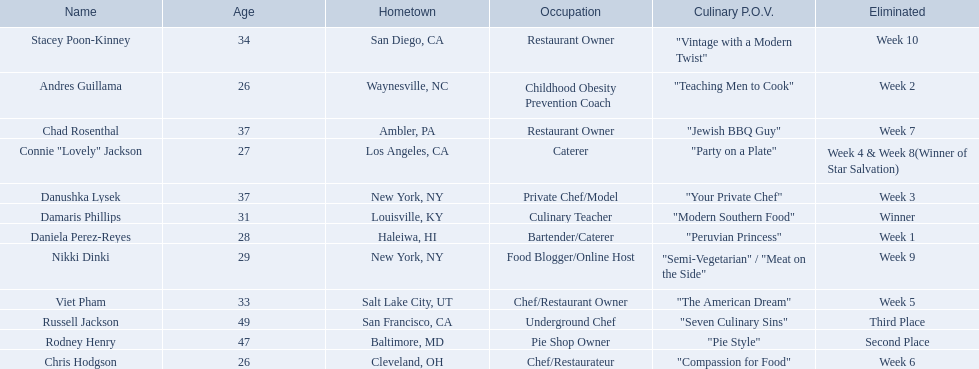Who are all of the people listed? Damaris Phillips, Rodney Henry, Russell Jackson, Stacey Poon-Kinney, Nikki Dinki, Chad Rosenthal, Chris Hodgson, Viet Pham, Connie "Lovely" Jackson, Danushka Lysek, Andres Guillama, Daniela Perez-Reyes. How old are they? 31, 47, 49, 34, 29, 37, 26, 33, 27, 37, 26, 28. Along with chris hodgson, which other person is 26 years old? Andres Guillama. 